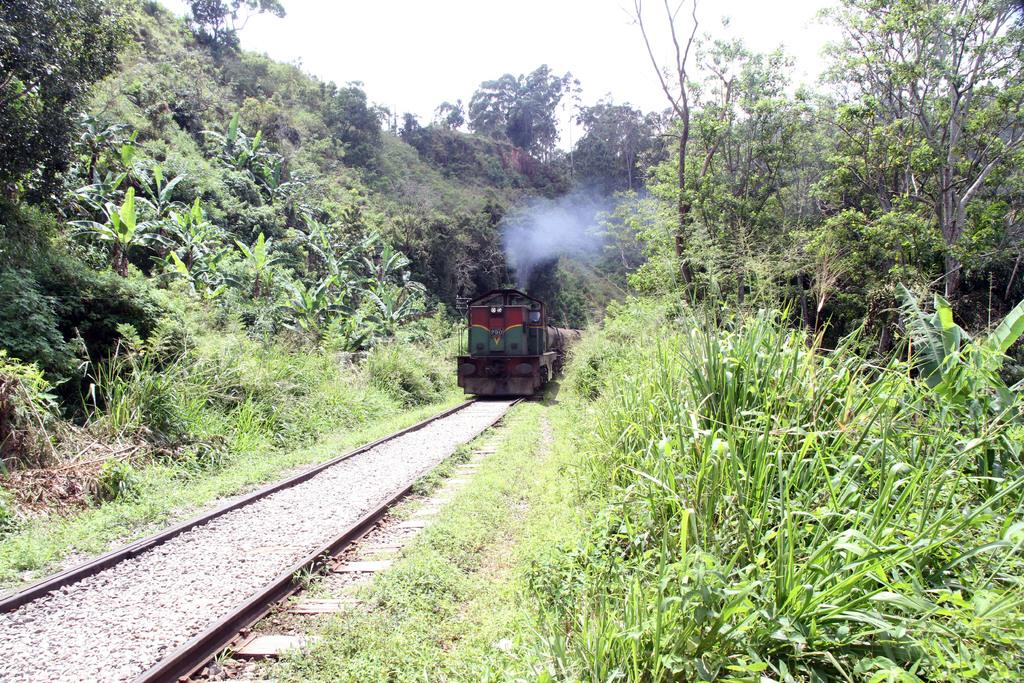What is the main subject of the image? The main subject of the image is a train. Where is the train located in the image? The train is on a railway track. What type of vegetation can be seen in the image? There are trees and grass visible in the image. What part of the natural environment is visible in the image? The sky is visible in the image. Can you tell me how many yaks are grazing on the trail in the image? There are no yaks or trails present in the image; it features a train on a railway track with trees, grass, and the sky visible. 